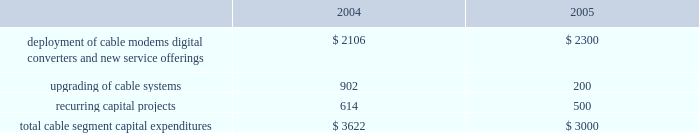Management 2019s discussion and analysis of financial condition and results of operations comcast corporation and subsidiaries28 comcast corporation and subsidiaries the exchangeable notes varies based upon the fair market value of the security to which it is indexed .
The exchangeable notes are collateralized by our investments in cablevision , microsoft and vodafone , respectively .
The comcast exchangeable notes are collateralized by our class a special common stock held in treasury .
We have settled and intend in the future to settle all of the comcast exchangeable notes using cash .
During 2004 and 2003 , we settled an aggregate of $ 847 million face amount and $ 638 million face amount , respectively , of our obligations relating to our notes exchangeable into comcast stock by delivering cash to the counterparty upon maturity of the instruments , and the equity collar agreements related to the underlying shares expired or were settled .
During 2004 and 2003 , we settled $ 2.359 billion face amount and $ 1.213 billion face amount , respectively , of our obligations relating to our exchangeable notes by delivering the underlying shares of common stock to the counterparty upon maturity of the investments .
As of december 31 , 2004 , our debt includes an aggregate of $ 1.699 billion of exchangeable notes , including $ 1.645 billion within current portion of long-term debt .
As of december 31 , 2004 , the securities we hold collateralizing the exchangeable notes were sufficient to substantially satisfy the debt obligations associated with the outstanding exchangeable notes .
Stock repurchases .
During 2004 , under our board-authorized , $ 2 billion share repurchase program , we repurchased 46.9 million shares of our class a special common stock for $ 1.328 billion .
We expect such repurchases to continue from time to time in the open market or in private transactions , subject to market conditions .
Refer to notes 8 and 10 to our consolidated financial statements for a discussion of our financing activities .
Investing activities net cash used in investing activities from continuing operations was $ 4.512 billion for the year ended december 31 , 2004 , and consists primarily of capital expenditures of $ 3.660 billion , additions to intangible and other noncurrent assets of $ 628 million and the acquisition of techtv for approximately $ 300 million .
Capital expenditures .
Our most significant recurring investing activity has been and is expected to continue to be capital expendi- tures .
The table illustrates the capital expenditures we incurred in our cable segment during 2004 and expect to incur in 2005 ( dollars in millions ) : .
The amount of our capital expenditures for 2005 and for subsequent years will depend on numerous factors , some of which are beyond our control , including competition , changes in technology and the timing and rate of deployment of new services .
Additions to intangibles .
Additions to intangibles during 2004 primarily relate to our investment in a $ 250 million long-term strategic license agreement with gemstar , multiple dwelling unit contracts of approximately $ 133 million and other licenses and software intangibles of approximately $ 168 million .
Investments .
Proceeds from sales , settlements and restructurings of investments totaled $ 228 million during 2004 , related to the sales of our non-strategic investments , including our 20% ( 20 % ) interest in dhc ventures , llc ( discovery health channel ) for approximately $ 149 million .
We consider investments that we determine to be non-strategic , highly-valued , or both to be a source of liquidity .
We consider our investment in $ 1.5 billion in time warner common-equivalent preferred stock to be an anticipated source of liquidity .
We do not have any significant contractual funding commitments with respect to any of our investments .
Refer to notes 6 and 7 to our consolidated financial statements for a discussion of our investments and our intangible assets , respectively .
Off-balance sheet arrangements we do not have any significant off-balance sheet arrangements that are reasonably likely to have a current or future effect on our financial condition , results of operations , liquidity , capital expenditures or capital resources. .
What was the percent of the total capital expenditures we incurred in our cable segment in 2004 for recurring capital projects? 
Computations: (614 / 3622)
Answer: 0.16952. 